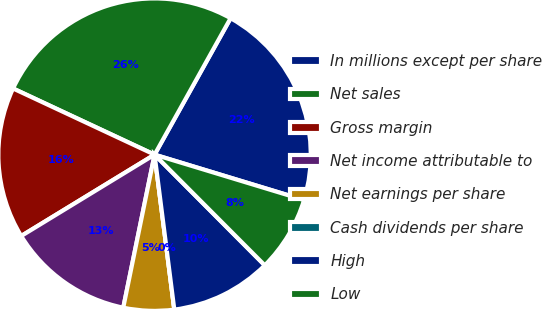Convert chart to OTSL. <chart><loc_0><loc_0><loc_500><loc_500><pie_chart><fcel>In millions except per share<fcel>Net sales<fcel>Gross margin<fcel>Net income attributable to<fcel>Net earnings per share<fcel>Cash dividends per share<fcel>High<fcel>Low<nl><fcel>21.6%<fcel>26.13%<fcel>15.68%<fcel>13.07%<fcel>5.23%<fcel>0.0%<fcel>10.45%<fcel>7.84%<nl></chart> 